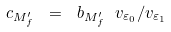<formula> <loc_0><loc_0><loc_500><loc_500>c _ { M ^ { \prime } _ { f } } \ = \ b _ { M ^ { \prime } _ { f } } \ v _ { { \varepsilon } _ { 0 } } / v _ { { \varepsilon } _ { 1 } }</formula> 